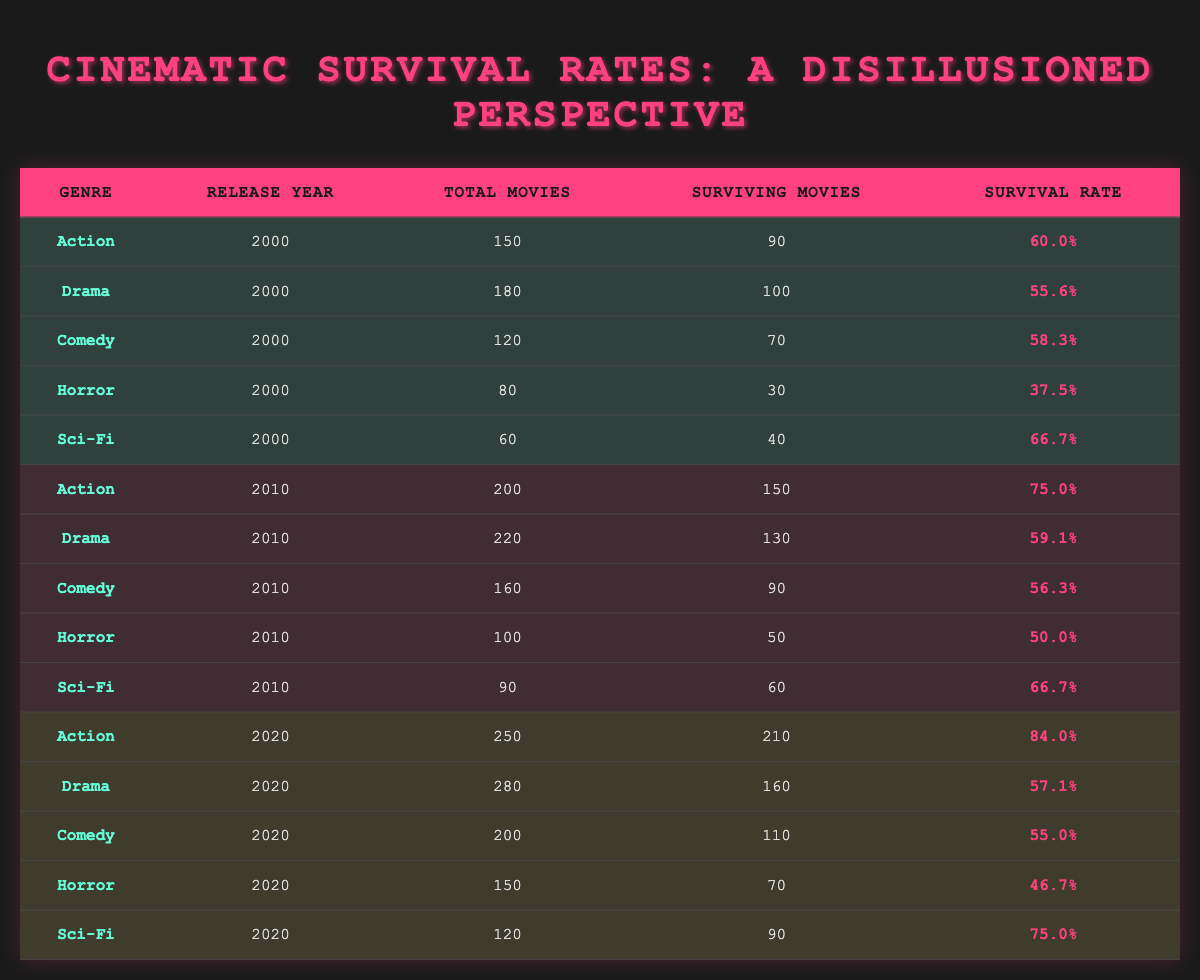What is the survival rate of Action movies released in 2020? From the table, we can see the row for Action movies in 2020 lists a survival rate of 84.0%.
Answer: 84.0% How many total Comedy movies were released in 2010? The data for Comedy in 2010 indicates a total of 160 movies.
Answer: 160 Which genre had the highest survival rate in 2000? The highest survival rate in 2000 was for Sci-Fi movies with a rate of 66.7%. This is compared to the survival rates of other genres listed for that year.
Answer: Sci-Fi What is the average survival rate for all genres in 2010? To find the average, add the survival rates for each genre in 2010 (75.0 + 59.1 + 56.3 + 50.0 + 66.7 = 307.1) and divide by the number of genres (5). Therefore, the average survival rate is 307.1 / 5 = 61.42%.
Answer: 61.42% Did Horror movies released in 2020 have a higher survival rate than those released in 2000? The survival rate for Horror movies in 2020 was 46.7%, while in 2000 it was 37.5%. Since 46.7% is greater than 37.5%, the statement is true.
Answer: Yes How many surviving Drama movies were there in 2010? According to the 2010 data, the number of surviving Drama movies is 130.
Answer: 130 What is the difference in survival rates between Action movies from 2010 and 2020? The survival rate for Action movies in 2010 is 75.0%, whereas in 2020 it is 84.0%. The difference is 84.0 - 75.0 = 9.0%.
Answer: 9.0% Which genre experienced the lowest survival rate overall across the years presented? Reviewing the data, Horror consistently has the lowest survival rates: 37.5% in 2000, 50.0% in 2010, and 46.7% in 2020. Therefore, Horror has the lowest overall average.
Answer: Horror How many total Comedy movies were released across all years presented? To find the total, sum the total movies for Comedy across all years: (120 in 2000) + (160 in 2010) + (200 in 2020) = 480.
Answer: 480 